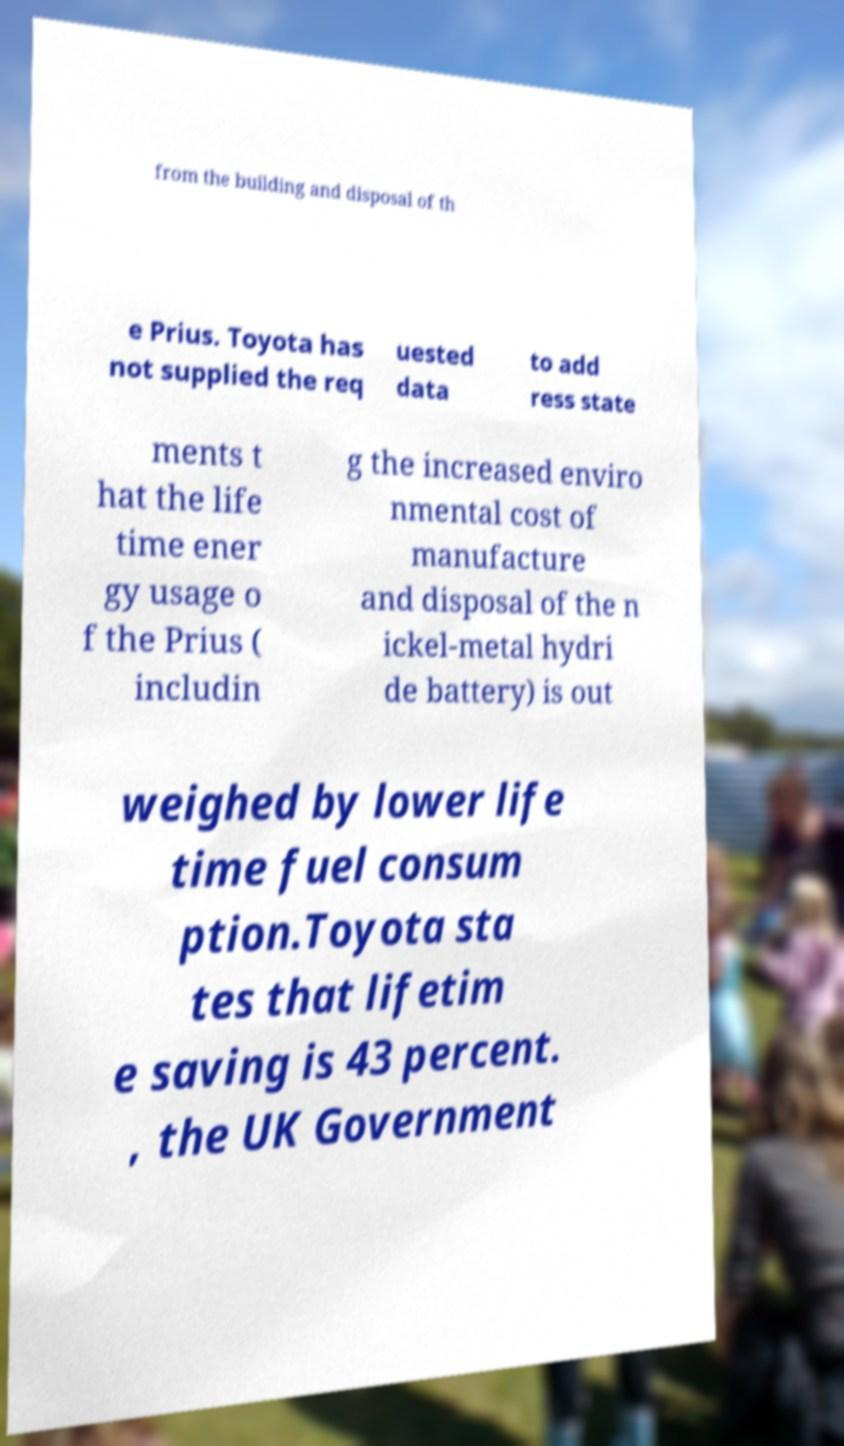Please identify and transcribe the text found in this image. from the building and disposal of th e Prius. Toyota has not supplied the req uested data to add ress state ments t hat the life time ener gy usage o f the Prius ( includin g the increased enviro nmental cost of manufacture and disposal of the n ickel-metal hydri de battery) is out weighed by lower life time fuel consum ption.Toyota sta tes that lifetim e saving is 43 percent. , the UK Government 